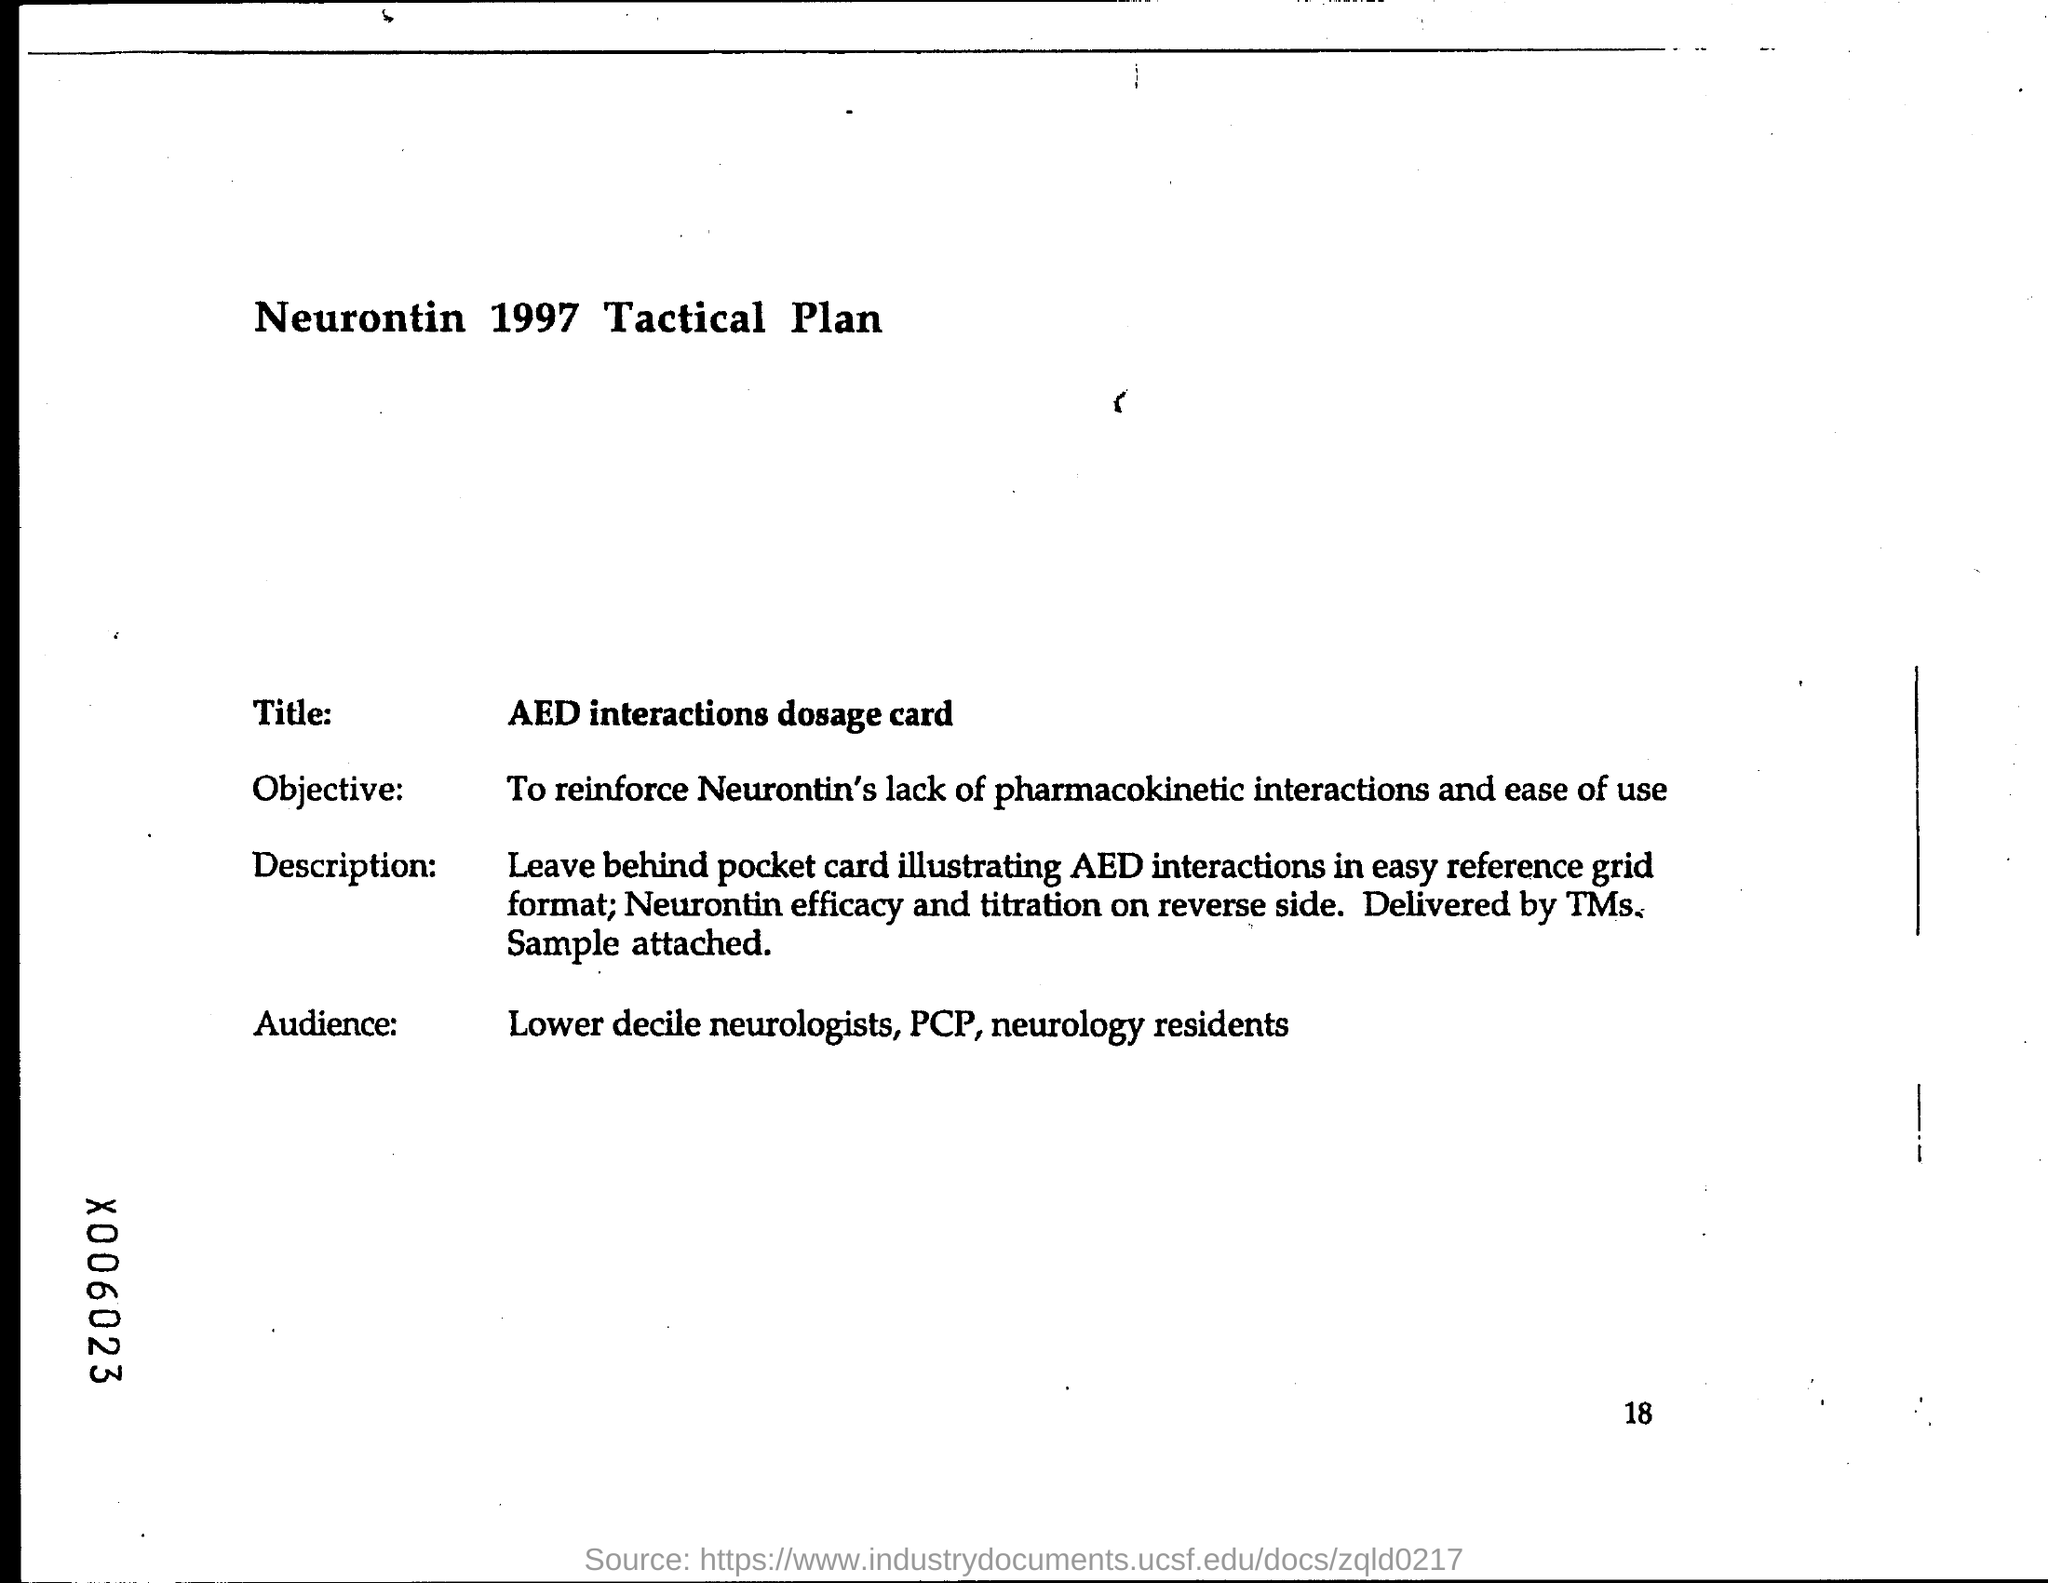Give some essential details in this illustration. The page number at the bottom of the page is 18. The title is 'What is the dosage for AED interactions?', which is a question about the appropriate amount of a substance to take when there is a potential interaction with a specific type of medication. 